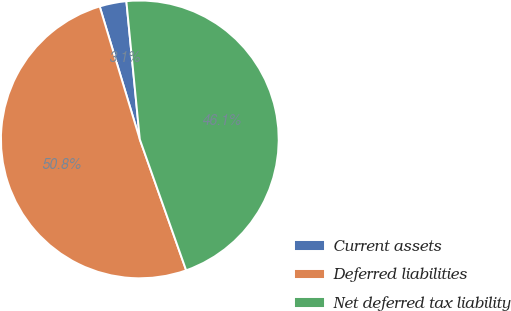<chart> <loc_0><loc_0><loc_500><loc_500><pie_chart><fcel>Current assets<fcel>Deferred liabilities<fcel>Net deferred tax liability<nl><fcel>3.12%<fcel>50.75%<fcel>46.13%<nl></chart> 